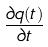<formula> <loc_0><loc_0><loc_500><loc_500>\frac { \partial q ( t ) } { \partial t }</formula> 